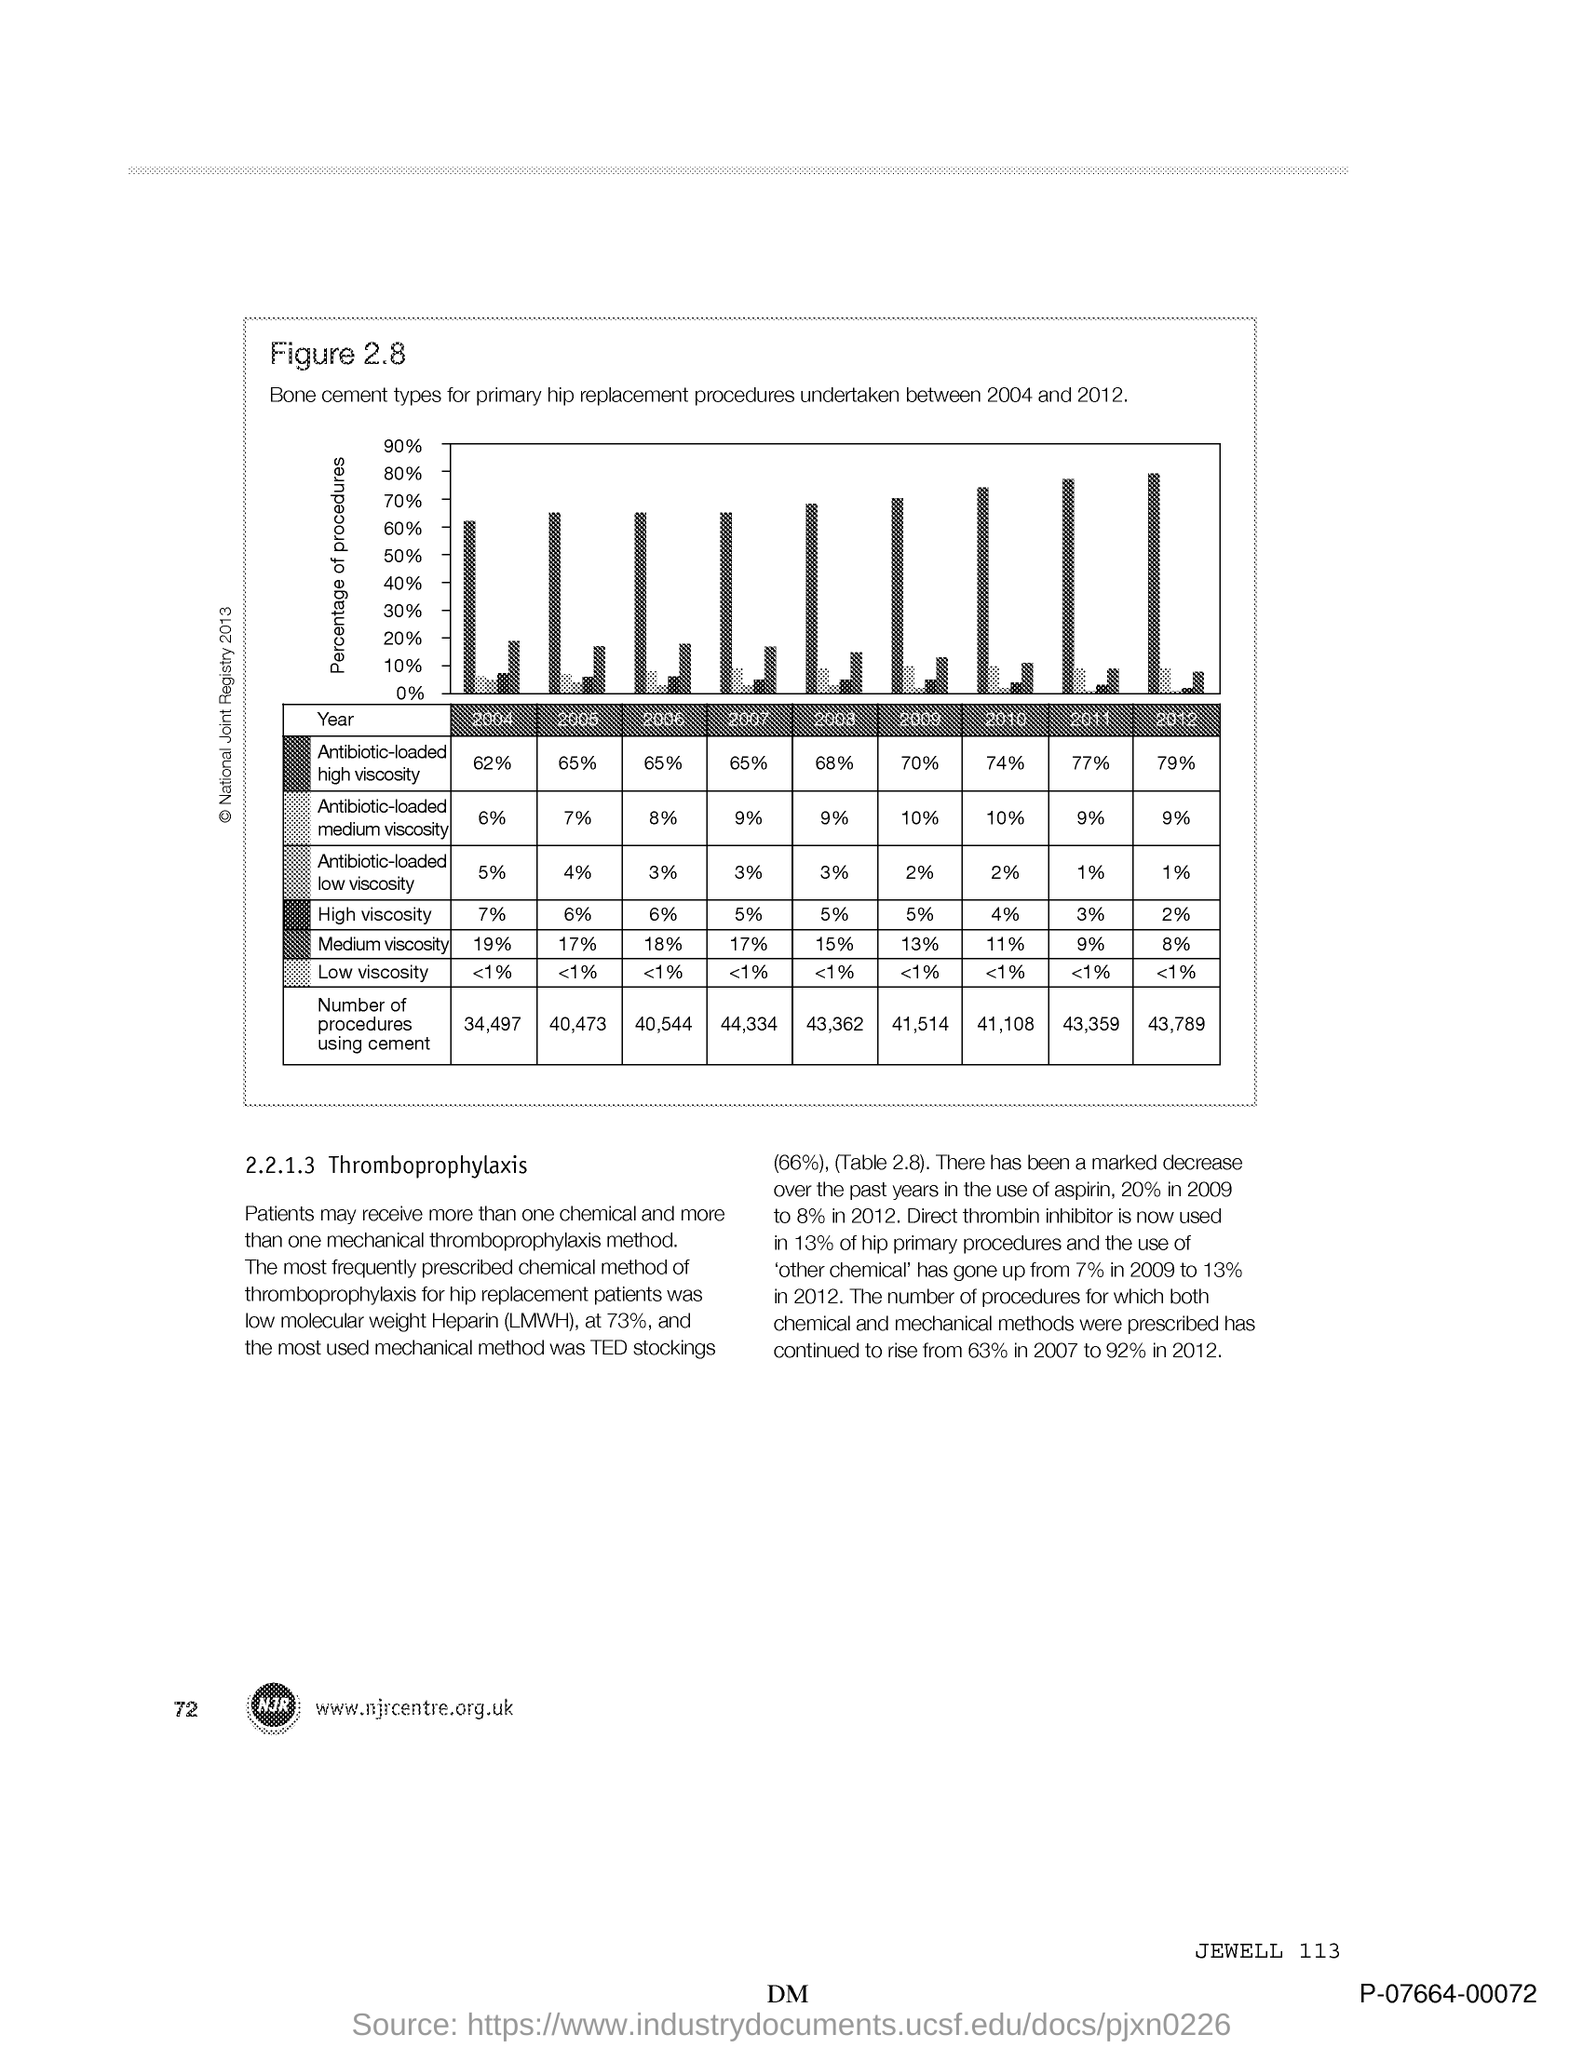Highlight a few significant elements in this photo. The y-axis in the plot displays the percentage of procedures performed on patients. 